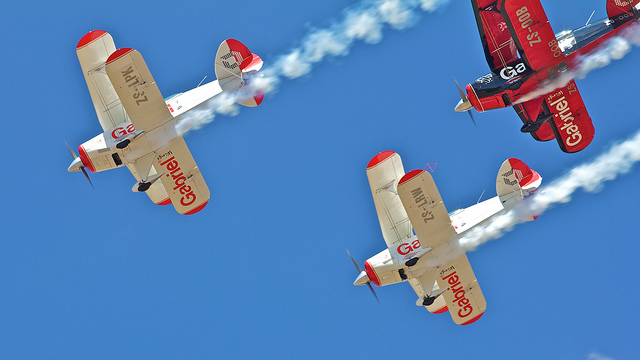How many planes can be seen?
Answer the question using a single word or phrase. 3 What is trailing behind the airplanes? Smoke Are these modern airplanes? No 